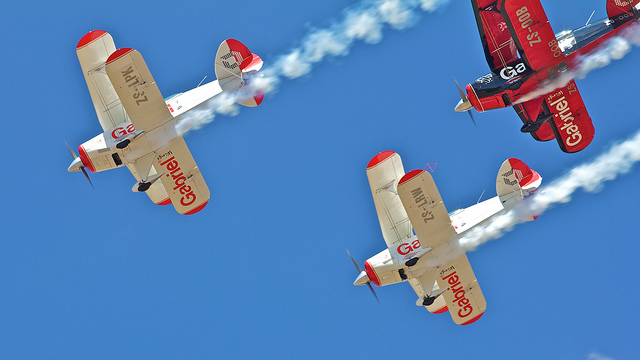How many planes can be seen?
Answer the question using a single word or phrase. 3 What is trailing behind the airplanes? Smoke Are these modern airplanes? No 